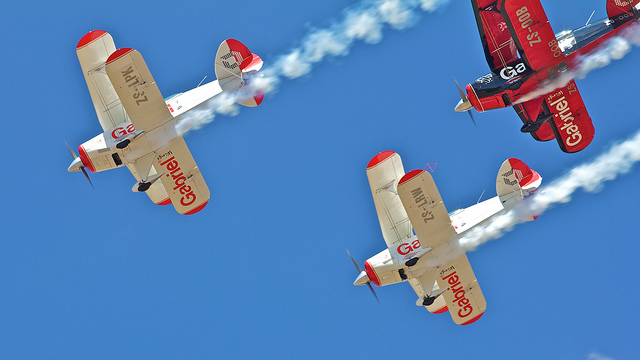How many planes can be seen?
Answer the question using a single word or phrase. 3 What is trailing behind the airplanes? Smoke Are these modern airplanes? No 